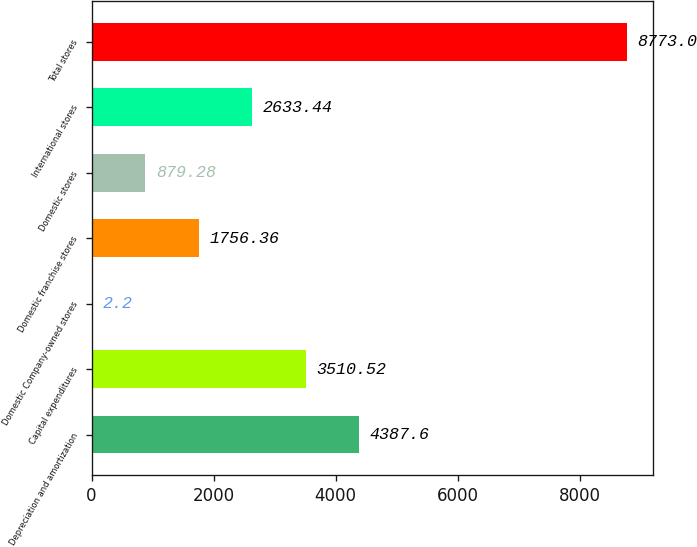Convert chart to OTSL. <chart><loc_0><loc_0><loc_500><loc_500><bar_chart><fcel>Depreciation and amortization<fcel>Capital expenditures<fcel>Domestic Company-owned stores<fcel>Domestic franchise stores<fcel>Domestic stores<fcel>International stores<fcel>Total stores<nl><fcel>4387.6<fcel>3510.52<fcel>2.2<fcel>1756.36<fcel>879.28<fcel>2633.44<fcel>8773<nl></chart> 